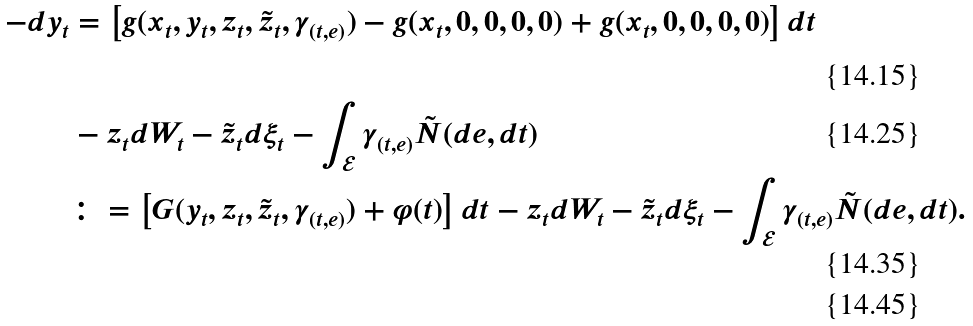Convert formula to latex. <formula><loc_0><loc_0><loc_500><loc_500>- d y _ { t } & = \left [ g ( x _ { t } , y _ { t } , z _ { t } , \tilde { z } _ { t } , \gamma _ { ( t , e ) } ) - g ( x _ { t } , 0 , 0 , 0 , 0 ) + g ( x _ { t } , 0 , 0 , 0 , 0 ) \right ] d t \\ & - z _ { t } d W _ { t } - \tilde { z } _ { t } d \xi _ { t } - \int _ { \mathcal { E } } \gamma _ { ( t , e ) } \tilde { N } ( d e , d t ) \\ & \colon = \left [ G ( y _ { t } , z _ { t } , \tilde { z } _ { t } , \gamma _ { ( t , e ) } ) + \varphi ( t ) \right ] d t - z _ { t } d W _ { t } - \tilde { z } _ { t } d \xi _ { t } - \int _ { \mathcal { E } } \gamma _ { ( t , e ) } \tilde { N } ( d e , d t ) . \\</formula> 